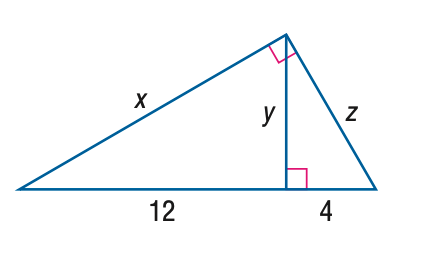Question: Find y.
Choices:
A. 4
B. 4 \sqrt { 3 }
C. 12
D. 8 \sqrt { 3 }
Answer with the letter. Answer: B Question: Find x.
Choices:
A. 8
B. 4 \sqrt { 6 }
C. 12
D. 8 \sqrt { 3 }
Answer with the letter. Answer: D Question: Find z.
Choices:
A. 4 \sqrt { 2 }
B. 4 \sqrt { 3 }
C. 8
D. 8 \sqrt { 3 }
Answer with the letter. Answer: C 